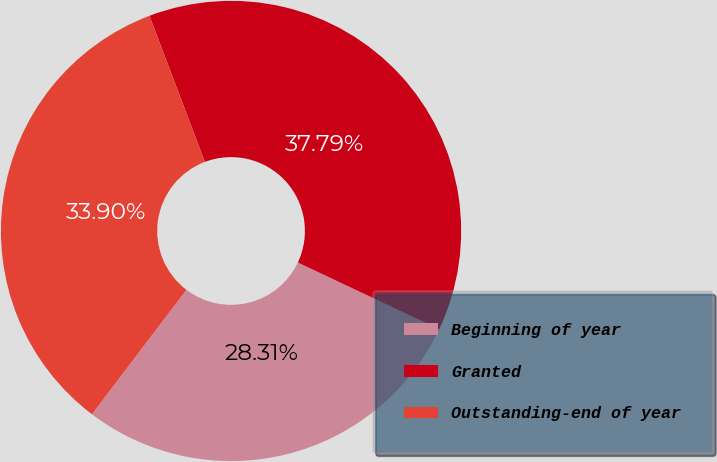Convert chart. <chart><loc_0><loc_0><loc_500><loc_500><pie_chart><fcel>Beginning of year<fcel>Granted<fcel>Outstanding-end of year<nl><fcel>28.31%<fcel>37.79%<fcel>33.9%<nl></chart> 